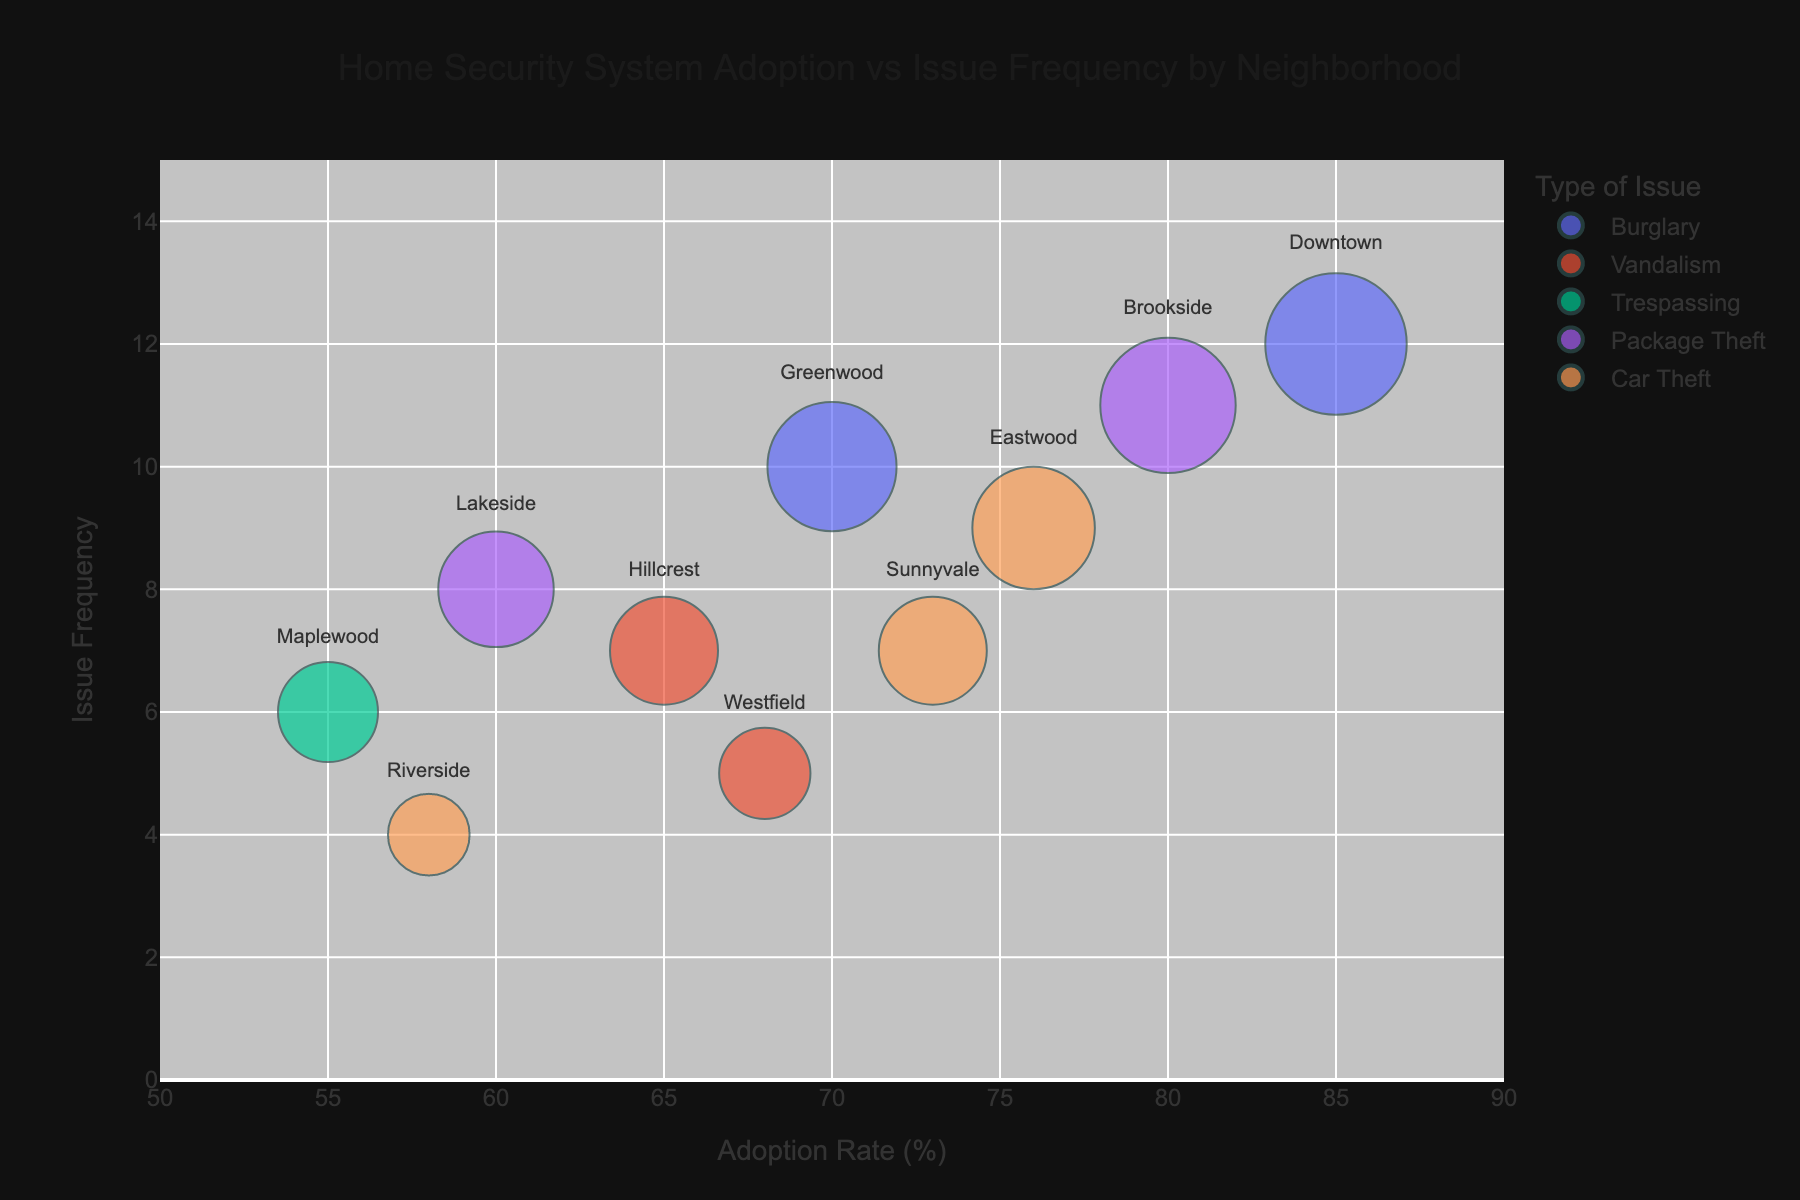What is the title of the chart? The title is usually displayed at the top of the chart, and it provides a summary of what the chart is about.
Answer: Home Security System Adoption vs Issue Frequency by Neighborhood How many neighborhoods are represented in the chart? Count the number of unique neighborhoods or data points in the chart. Each neighborhood has a data point that can be seen upon hovering over the bubbles.
Answer: 10 What does the size of the bubbles represent? The size of the bubbles typically corresponds to a certain variable. In this chart, it is mentioned as 'size='IssueFrequency''.
Answer: IssueFrequency Which neighborhood has the highest adoption rate of home security systems? Look at the horizontal axis (Adoption Rate) and identify the data point that is positioned furthest to the right.
Answer: Downtown **Compositional questions**
 
What is the average adoption rate of home security systems across all neighborhoods? Sum all adoption rates and divide by the number of neighborhoods: (70+65+85+55+60+76+68+73+80+58)/10 = 69.
Answer: 69 What is the sum of the issue frequencies for neighborhoods reporting Burglary? Identify the bubbles colored for Burglary and sum their issue frequencies. Greenwood and Downtown are the neighborhoods reporting Burglary with frequencies 10 and 12. 10 + 12 = 22
Answer: 22 Which neighborhood has a higher issue frequency, Eastwood or Sunnyvale? Compare the vertical position of the bubbles for Eastwood and Sunnyvale since the y-axis represents Issue Frequency. Eastwood has an issue frequency of 9, and Sunnyvale has an issue frequency of 7.
Answer: Eastwood Which issue type is associated with the neighborhood that has the lowest adoption rate? Identify the bubble with the lowest horizontal position (lowest adoption rate) and check its color or hover label for the issue type. Maplewood has the lowest adoption rate at 55%, and it is associated with Trespassing.
Answer: Trespassing Which neighborhood appears largest in bubble size and what does it signify? Look for the largest bubble size in the chart which represents the highest Issue Frequency. Brookside has the largest bubble size with an Issue Frequency of 11.
Answer: Brookside Which neighborhoods show an obvious correlation between high adoption rate and high issue frequency? Identify neighborhoods with higher positions on both x-axis and y-axis (top right area). Both Downtown and Brookside show high adoption rates (85% and 80%) and high issue frequencies (12 and 11 respectively).
Answer: Downtown and Brookside 